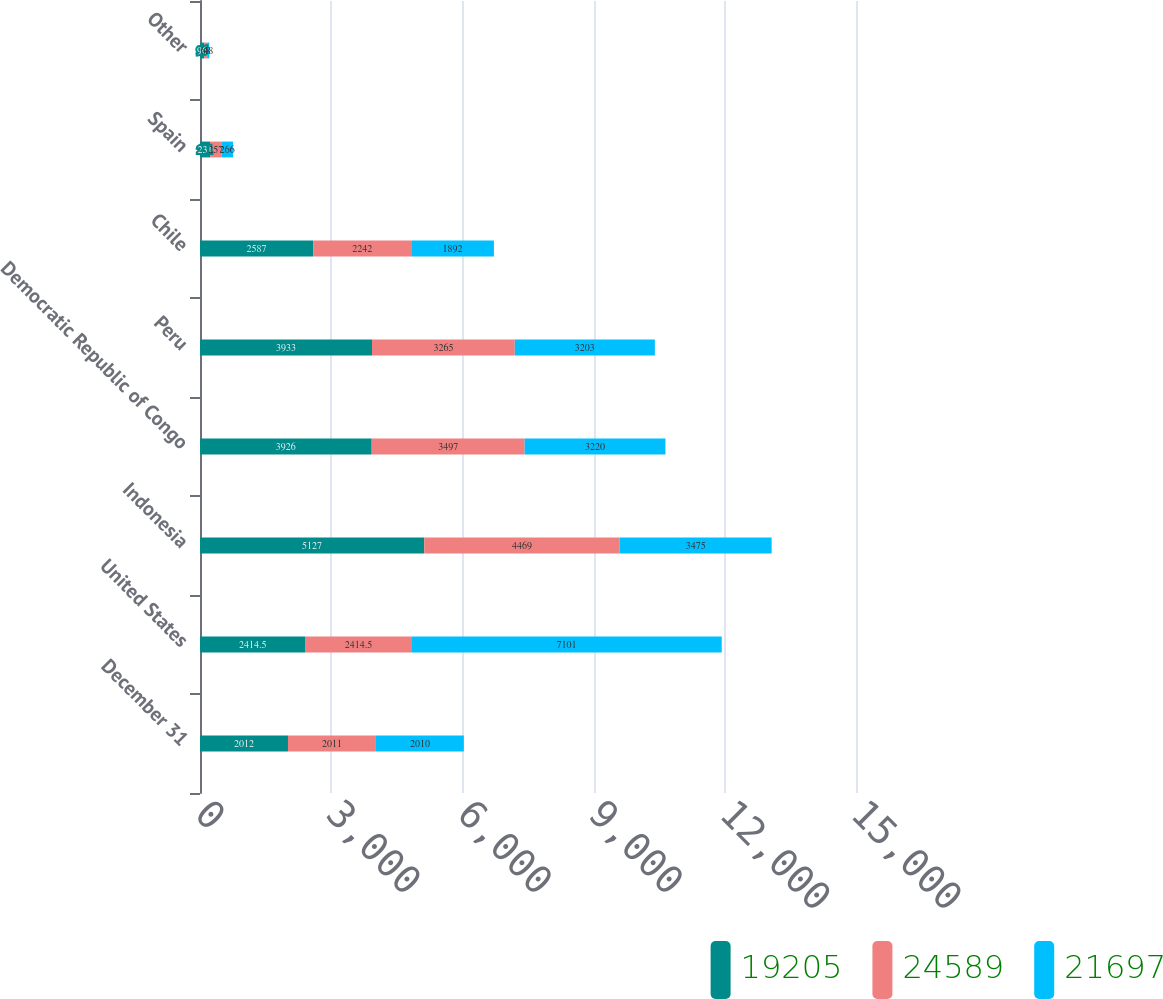Convert chart. <chart><loc_0><loc_0><loc_500><loc_500><stacked_bar_chart><ecel><fcel>December 31<fcel>United States<fcel>Indonesia<fcel>Democratic Republic of Congo<fcel>Peru<fcel>Chile<fcel>Spain<fcel>Other<nl><fcel>19205<fcel>2012<fcel>2414.5<fcel>5127<fcel>3926<fcel>3933<fcel>2587<fcel>231<fcel>96<nl><fcel>24589<fcel>2011<fcel>2414.5<fcel>4469<fcel>3497<fcel>3265<fcel>2242<fcel>257<fcel>68<nl><fcel>21697<fcel>2010<fcel>7101<fcel>3475<fcel>3220<fcel>3203<fcel>1892<fcel>266<fcel>48<nl></chart> 